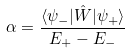<formula> <loc_0><loc_0><loc_500><loc_500>\alpha = \frac { \langle \psi _ { - } | \hat { W } | \psi _ { + } \rangle } { E _ { + } - E _ { - } }</formula> 